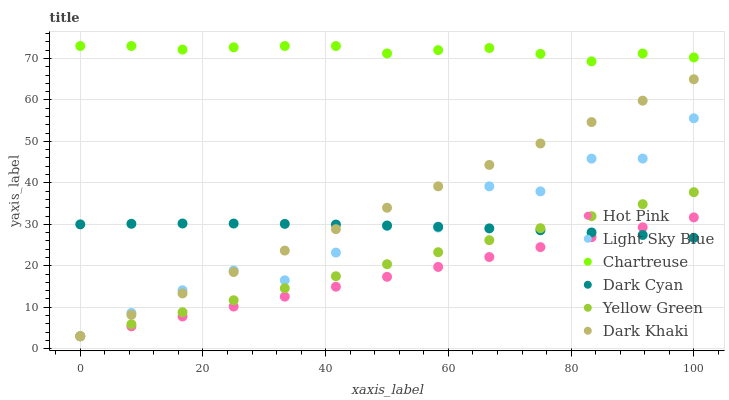Does Hot Pink have the minimum area under the curve?
Answer yes or no. Yes. Does Chartreuse have the maximum area under the curve?
Answer yes or no. Yes. Does Dark Khaki have the minimum area under the curve?
Answer yes or no. No. Does Dark Khaki have the maximum area under the curve?
Answer yes or no. No. Is Hot Pink the smoothest?
Answer yes or no. Yes. Is Light Sky Blue the roughest?
Answer yes or no. Yes. Is Dark Khaki the smoothest?
Answer yes or no. No. Is Dark Khaki the roughest?
Answer yes or no. No. Does Yellow Green have the lowest value?
Answer yes or no. Yes. Does Chartreuse have the lowest value?
Answer yes or no. No. Does Chartreuse have the highest value?
Answer yes or no. Yes. Does Hot Pink have the highest value?
Answer yes or no. No. Is Dark Khaki less than Chartreuse?
Answer yes or no. Yes. Is Chartreuse greater than Hot Pink?
Answer yes or no. Yes. Does Yellow Green intersect Dark Cyan?
Answer yes or no. Yes. Is Yellow Green less than Dark Cyan?
Answer yes or no. No. Is Yellow Green greater than Dark Cyan?
Answer yes or no. No. Does Dark Khaki intersect Chartreuse?
Answer yes or no. No. 